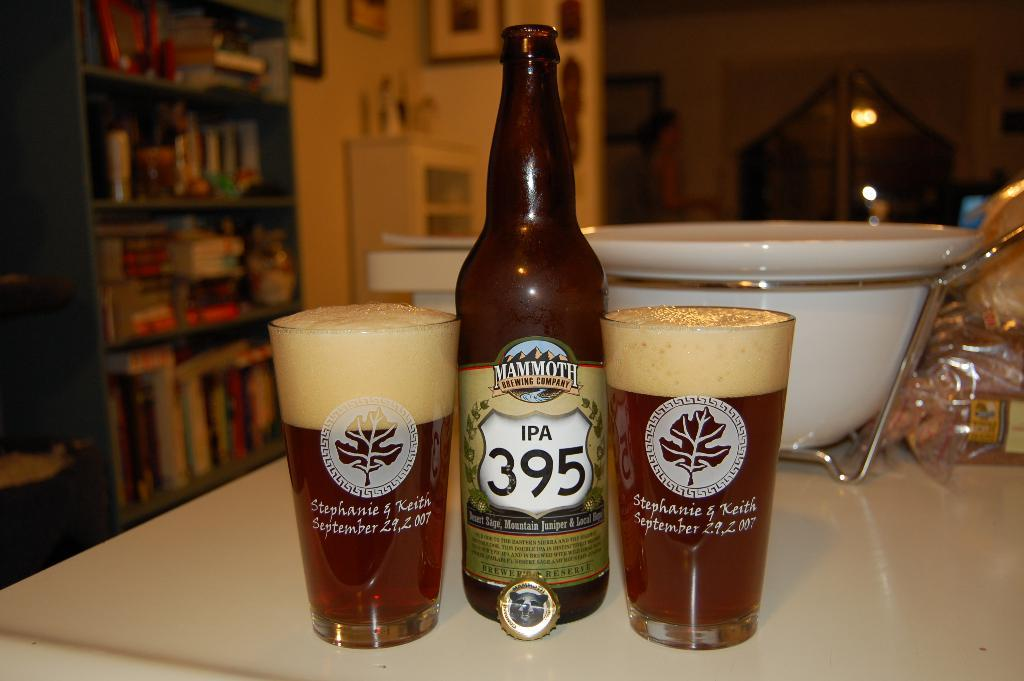<image>
Offer a succinct explanation of the picture presented. Two glasses and bottle of Mammoth Brewing Company IPA 395 